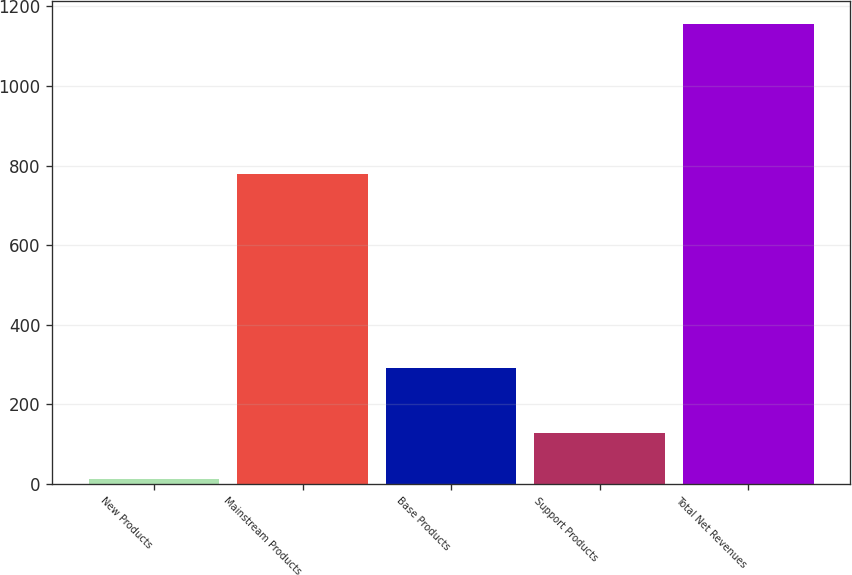<chart> <loc_0><loc_0><loc_500><loc_500><bar_chart><fcel>New Products<fcel>Mainstream Products<fcel>Base Products<fcel>Support Products<fcel>Total Net Revenues<nl><fcel>13<fcel>779.4<fcel>292.5<fcel>127.3<fcel>1156<nl></chart> 